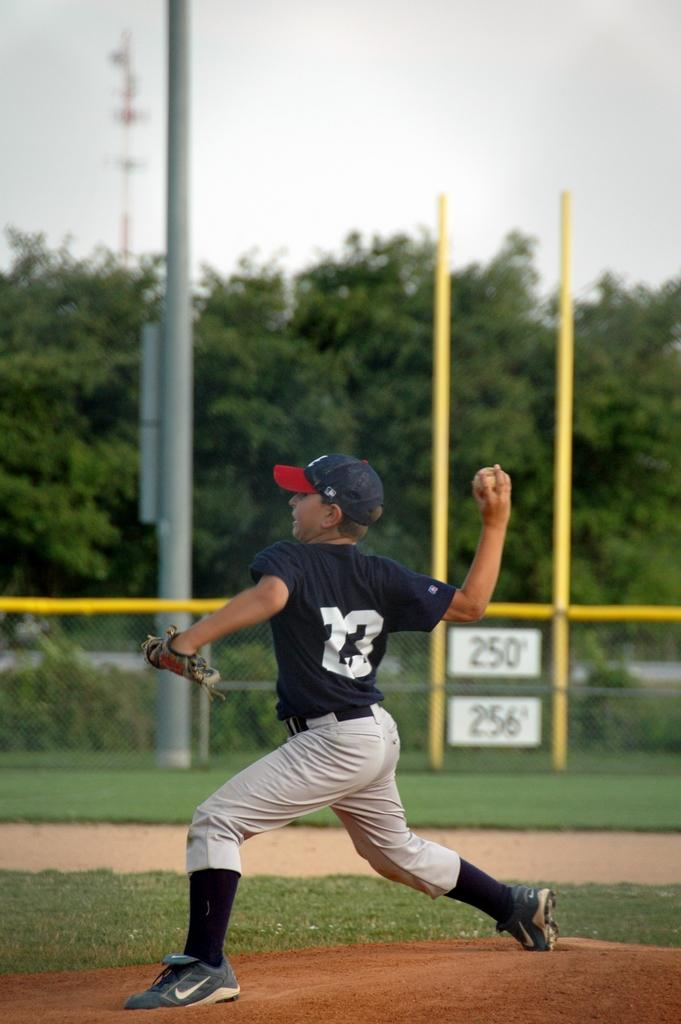<image>
Share a concise interpretation of the image provided. A boy in a 22 shirt playing baseball and throwing a ball. 